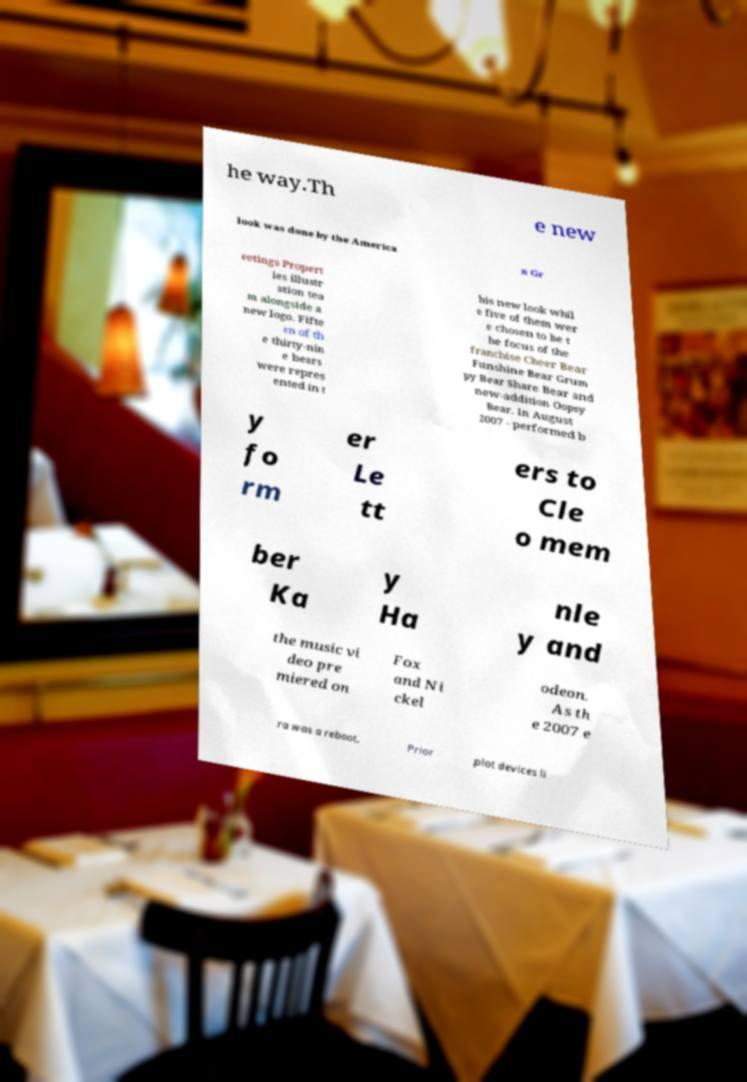Please identify and transcribe the text found in this image. he way.Th e new look was done by the America n Gr eetings Propert ies illustr ation tea m alongside a new logo. Fifte en of th e thirty-nin e bears were repres ented in t his new look whil e five of them wer e chosen to be t he focus of the franchise Cheer Bear Funshine Bear Grum py Bear Share Bear and new-addition Oopsy Bear. In August 2007 - performed b y fo rm er Le tt ers to Cle o mem ber Ka y Ha nle y and the music vi deo pre miered on Fox and Ni ckel odeon. As th e 2007 e ra was a reboot, Prior plot devices li 